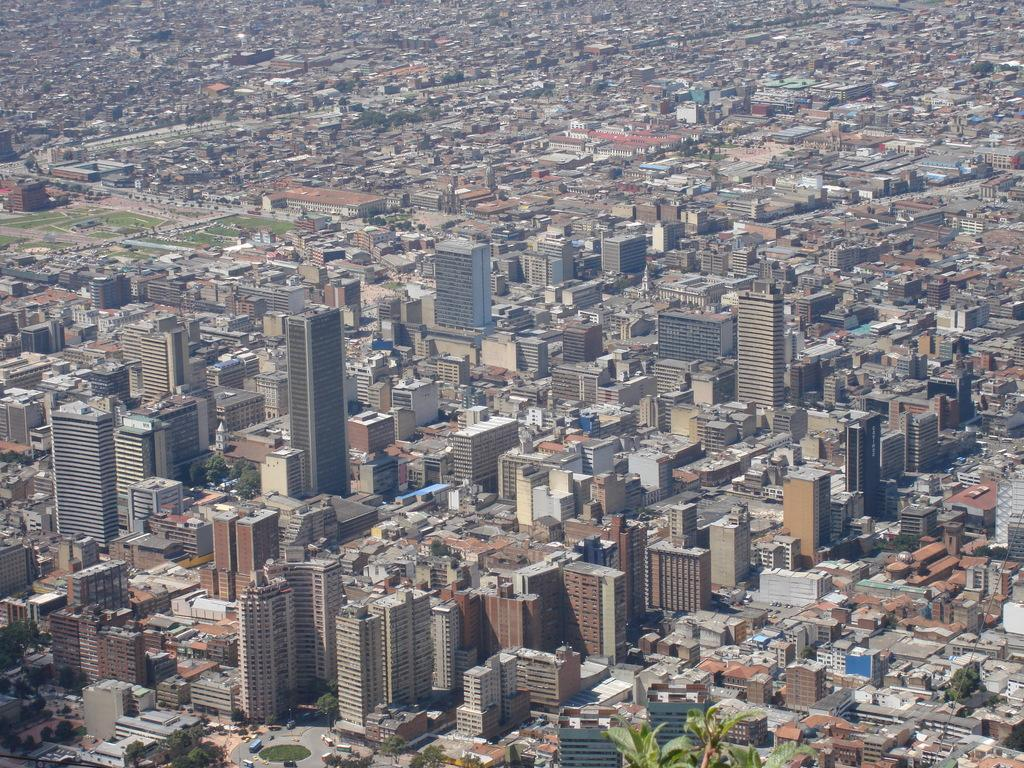What type of view is shown in the image? The image is an aerial view. What structures can be seen in the image? There are buildings and tower buildings in the image. What else is visible in the image besides buildings? There is a road and trees visible in the image. How many seeds are planted in the trees visible in the image? There is no information about seeds in the image, as it focuses on the aerial view of buildings, tower buildings, a road, and trees. 